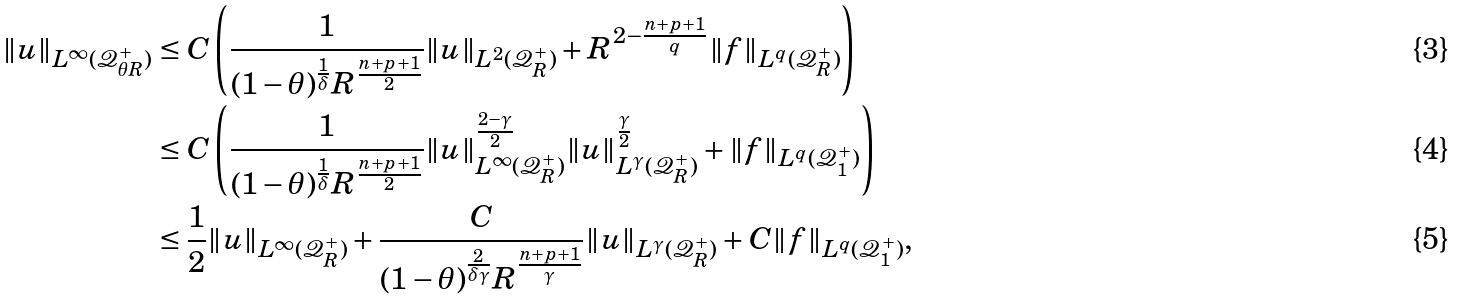<formula> <loc_0><loc_0><loc_500><loc_500>\| u \| _ { L ^ { \infty } ( \mathcal { Q } _ { \theta R } ^ { + } ) } & \leq C \left ( \frac { 1 } { ( 1 - \theta ) ^ { \frac { 1 } { \delta } } R ^ { \frac { n + p + 1 } { 2 } } } \| u \| _ { L ^ { 2 } ( \mathcal { Q } _ { R } ^ { + } ) } + R ^ { 2 - \frac { n + p + 1 } { q } } \| f \| _ { L ^ { q } ( \mathcal { Q } _ { R } ^ { + } ) } \right ) \\ & \leq C \left ( \frac { 1 } { ( 1 - \theta ) ^ { \frac { 1 } { \delta } } R ^ { \frac { n + p + 1 } { 2 } } } \| u \| _ { L ^ { \infty } ( \mathcal { Q } _ { R } ^ { + } ) } ^ { \frac { 2 - \gamma } { 2 } } \| u \| _ { L ^ { \gamma } ( \mathcal { Q } _ { R } ^ { + } ) } ^ { \frac { \gamma } { 2 } } + \| f \| _ { L ^ { q } ( \mathcal { Q } _ { 1 } ^ { + } ) } \right ) \\ & \leq \frac { 1 } { 2 } \| u \| _ { L ^ { \infty } ( \mathcal { Q } _ { R } ^ { + } ) } + \frac { C } { ( 1 - \theta ) ^ { \frac { 2 } { \delta \gamma } } R ^ { \frac { n + p + 1 } { \gamma } } } \| u \| _ { L ^ { \gamma } ( \mathcal { Q } _ { R } ^ { + } ) } + C \| f \| _ { L ^ { q } ( \mathcal { Q } _ { 1 } ^ { + } ) } ,</formula> 